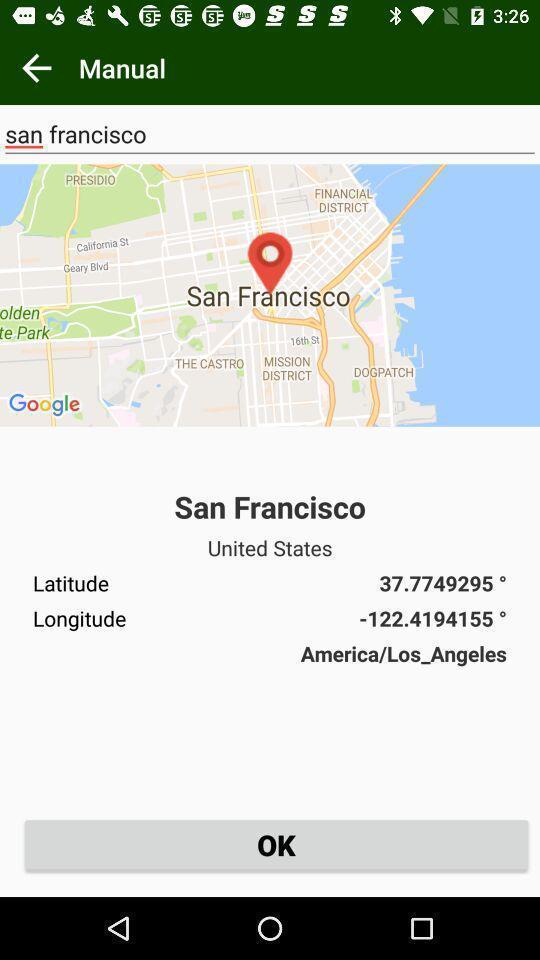Give me a summary of this screen capture. Screen shows map with ok option. 